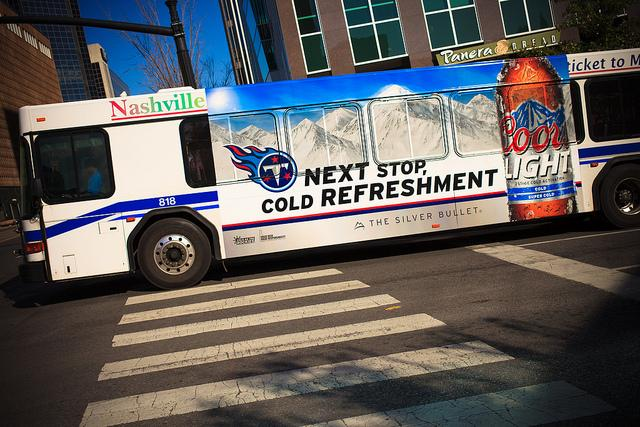Who is the road for? cars 